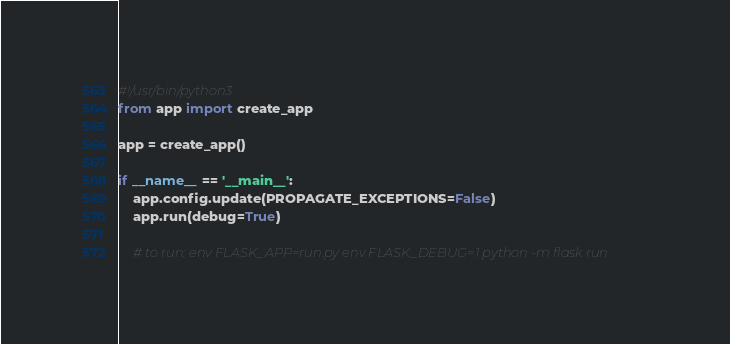Convert code to text. <code><loc_0><loc_0><loc_500><loc_500><_Python_>#!/usr/bin/python3
from app import create_app

app = create_app()

if __name__ == '__main__':
    app.config.update(PROPAGATE_EXCEPTIONS=False)
    app.run(debug=True)

    # to run: env FLASK_APP=run.py env FLASK_DEBUG=1 python -m flask run
</code> 